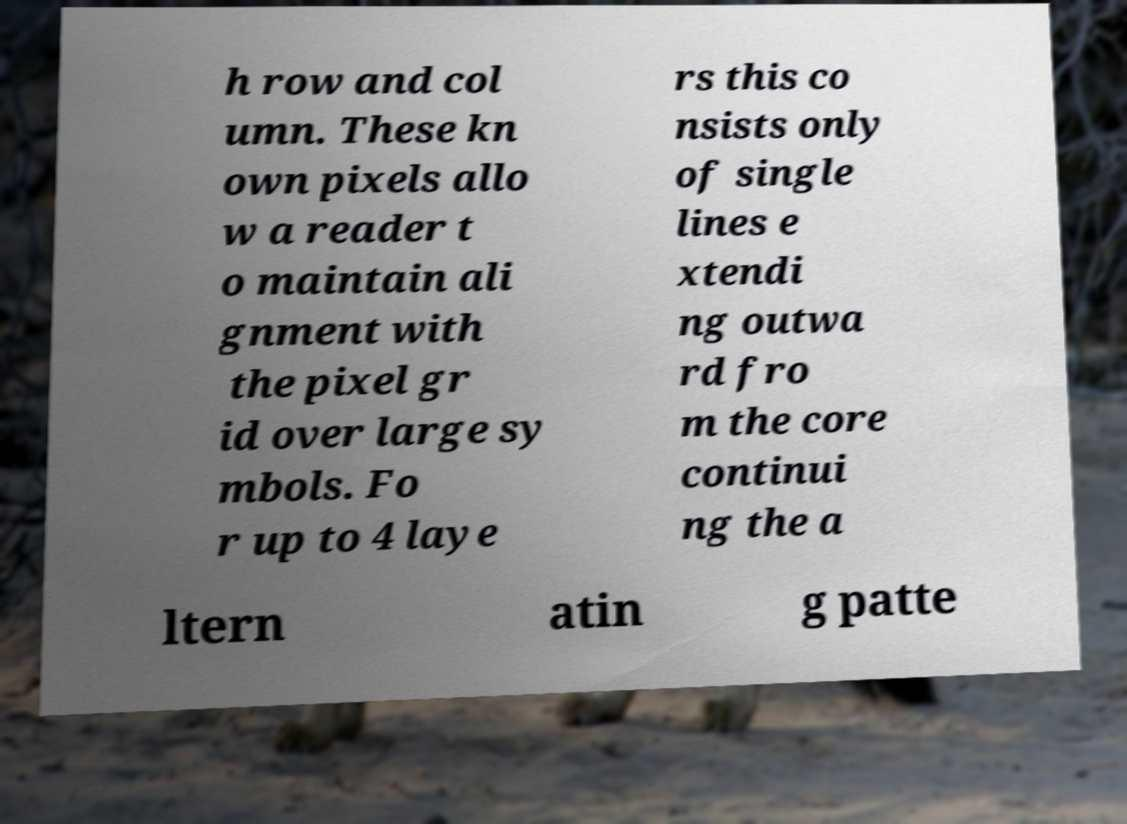Please identify and transcribe the text found in this image. h row and col umn. These kn own pixels allo w a reader t o maintain ali gnment with the pixel gr id over large sy mbols. Fo r up to 4 laye rs this co nsists only of single lines e xtendi ng outwa rd fro m the core continui ng the a ltern atin g patte 